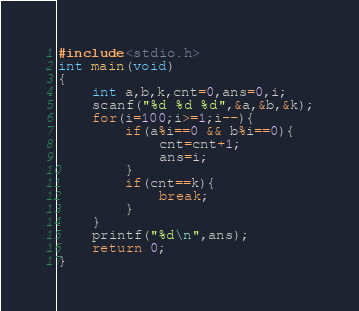<code> <loc_0><loc_0><loc_500><loc_500><_C_>#include<stdio.h>
int main(void)
{
	int a,b,k,cnt=0,ans=0,i;
	scanf("%d %d %d",&a,&b,&k);
	for(i=100;i>=1;i--){
		if(a%i==0 && b%i==0){
			cnt=cnt+1;
			ans=i;
		}
		if(cnt==k){
			break;
		}
	}
	printf("%d\n",ans);
	return 0;
}</code> 